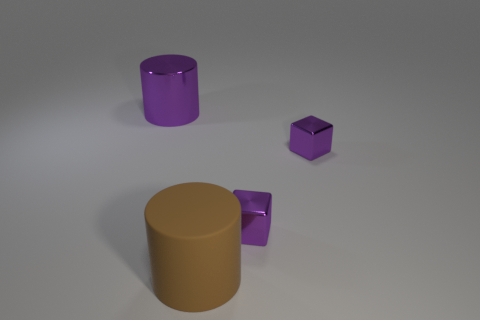Add 3 matte objects. How many objects exist? 7 Subtract 1 cylinders. How many cylinders are left? 1 Subtract all rubber objects. Subtract all small purple metal things. How many objects are left? 1 Add 3 tiny purple cubes. How many tiny purple cubes are left? 5 Add 3 purple things. How many purple things exist? 6 Subtract 0 cyan cubes. How many objects are left? 4 